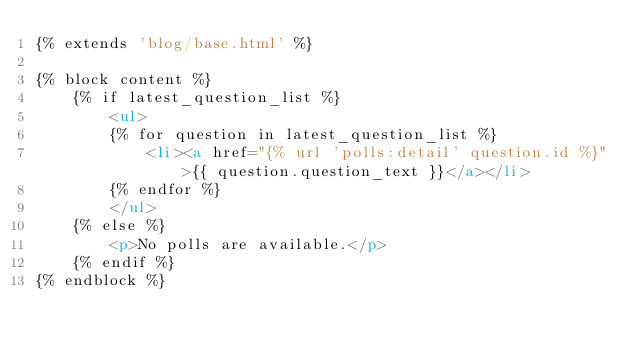<code> <loc_0><loc_0><loc_500><loc_500><_HTML_>{% extends 'blog/base.html' %}

{% block content %}
    {% if latest_question_list %}
        <ul>
        {% for question in latest_question_list %}
            <li><a href="{% url 'polls:detail' question.id %}">{{ question.question_text }}</a></li>
        {% endfor %}
        </ul>
    {% else %}
        <p>No polls are available.</p>
    {% endif %}
{% endblock %}
</code> 